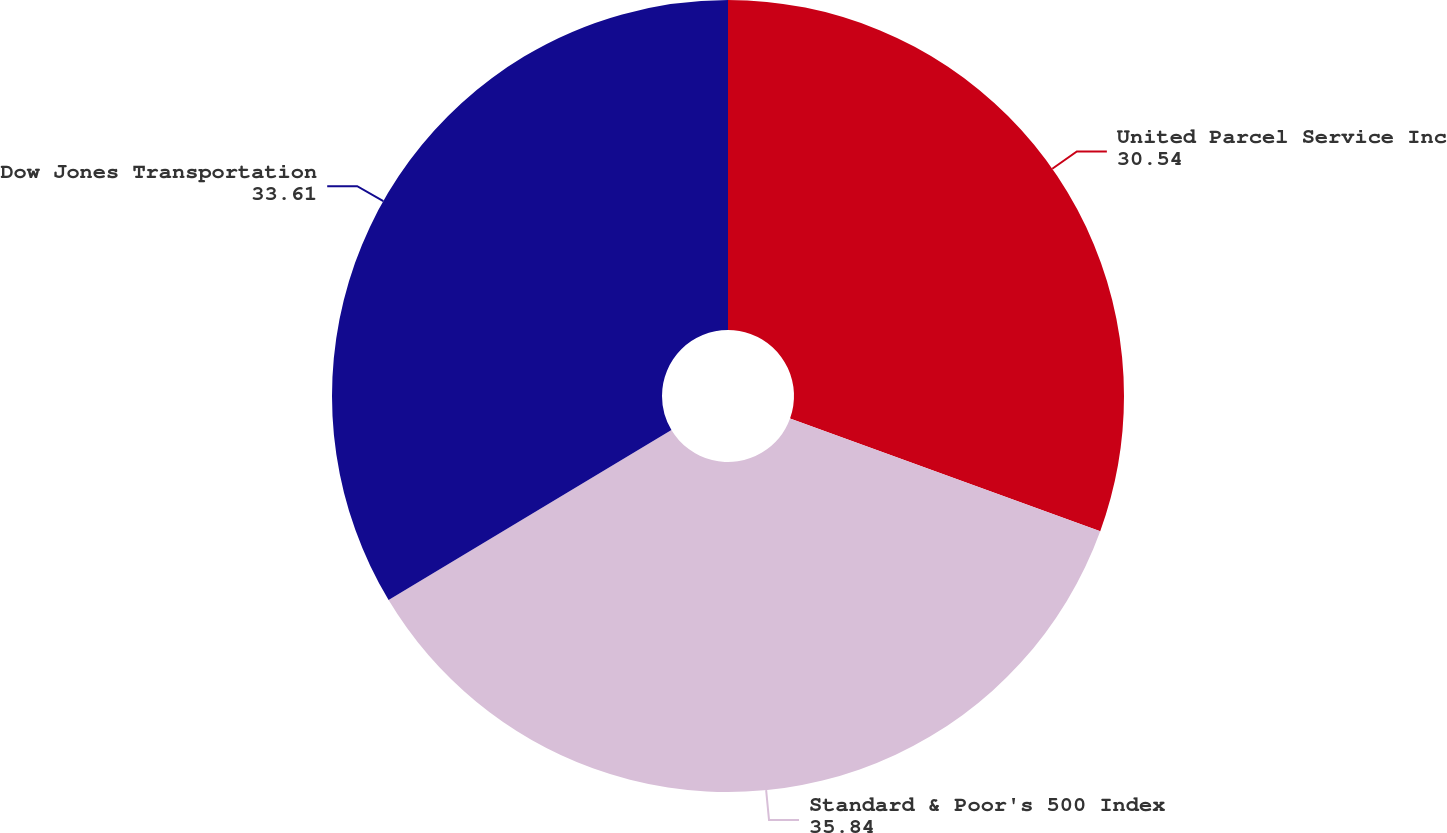<chart> <loc_0><loc_0><loc_500><loc_500><pie_chart><fcel>United Parcel Service Inc<fcel>Standard & Poor's 500 Index<fcel>Dow Jones Transportation<nl><fcel>30.54%<fcel>35.84%<fcel>33.61%<nl></chart> 